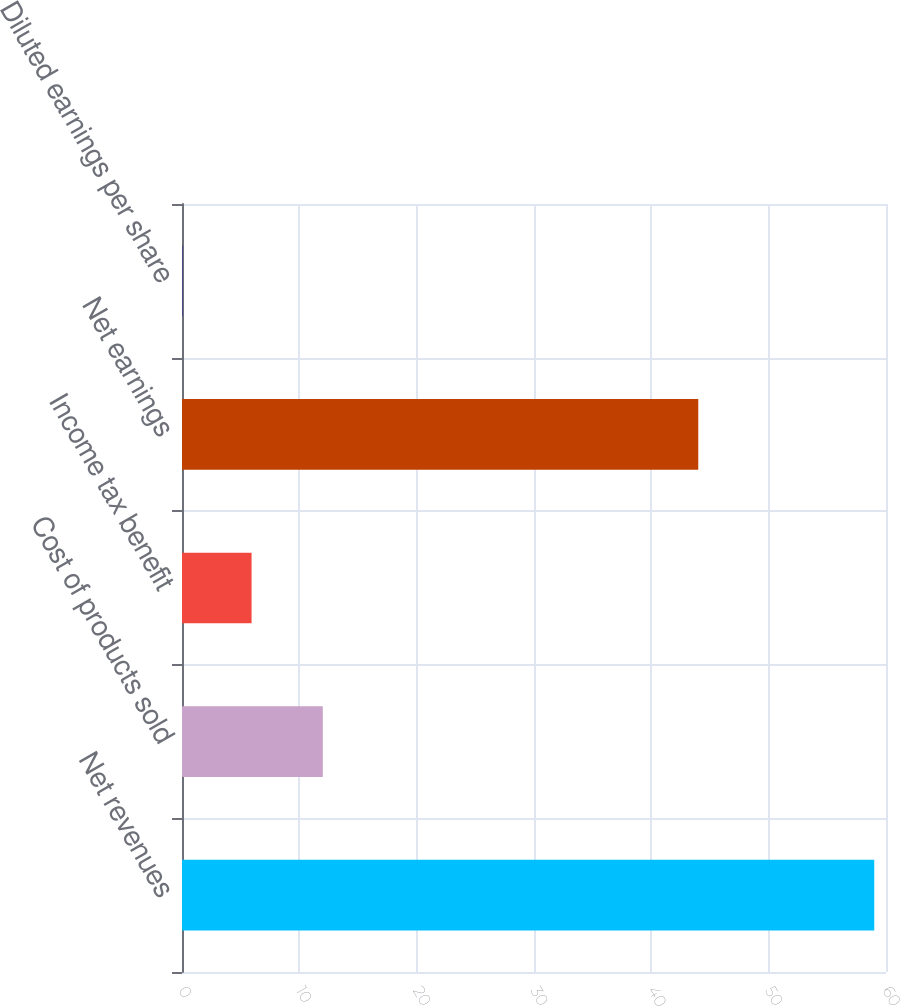<chart> <loc_0><loc_0><loc_500><loc_500><bar_chart><fcel>Net revenues<fcel>Cost of products sold<fcel>Income tax benefit<fcel>Net earnings<fcel>Diluted earnings per share<nl><fcel>59<fcel>12<fcel>5.93<fcel>44<fcel>0.03<nl></chart> 